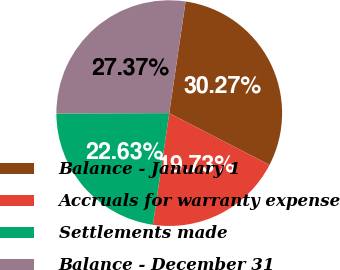Convert chart. <chart><loc_0><loc_0><loc_500><loc_500><pie_chart><fcel>Balance - January 1<fcel>Accruals for warranty expense<fcel>Settlements made<fcel>Balance - December 31<nl><fcel>30.27%<fcel>19.73%<fcel>22.63%<fcel>27.37%<nl></chart> 